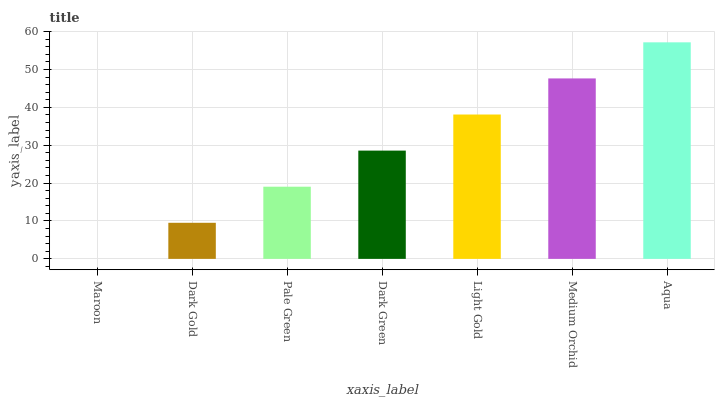Is Maroon the minimum?
Answer yes or no. Yes. Is Aqua the maximum?
Answer yes or no. Yes. Is Dark Gold the minimum?
Answer yes or no. No. Is Dark Gold the maximum?
Answer yes or no. No. Is Dark Gold greater than Maroon?
Answer yes or no. Yes. Is Maroon less than Dark Gold?
Answer yes or no. Yes. Is Maroon greater than Dark Gold?
Answer yes or no. No. Is Dark Gold less than Maroon?
Answer yes or no. No. Is Dark Green the high median?
Answer yes or no. Yes. Is Dark Green the low median?
Answer yes or no. Yes. Is Pale Green the high median?
Answer yes or no. No. Is Maroon the low median?
Answer yes or no. No. 